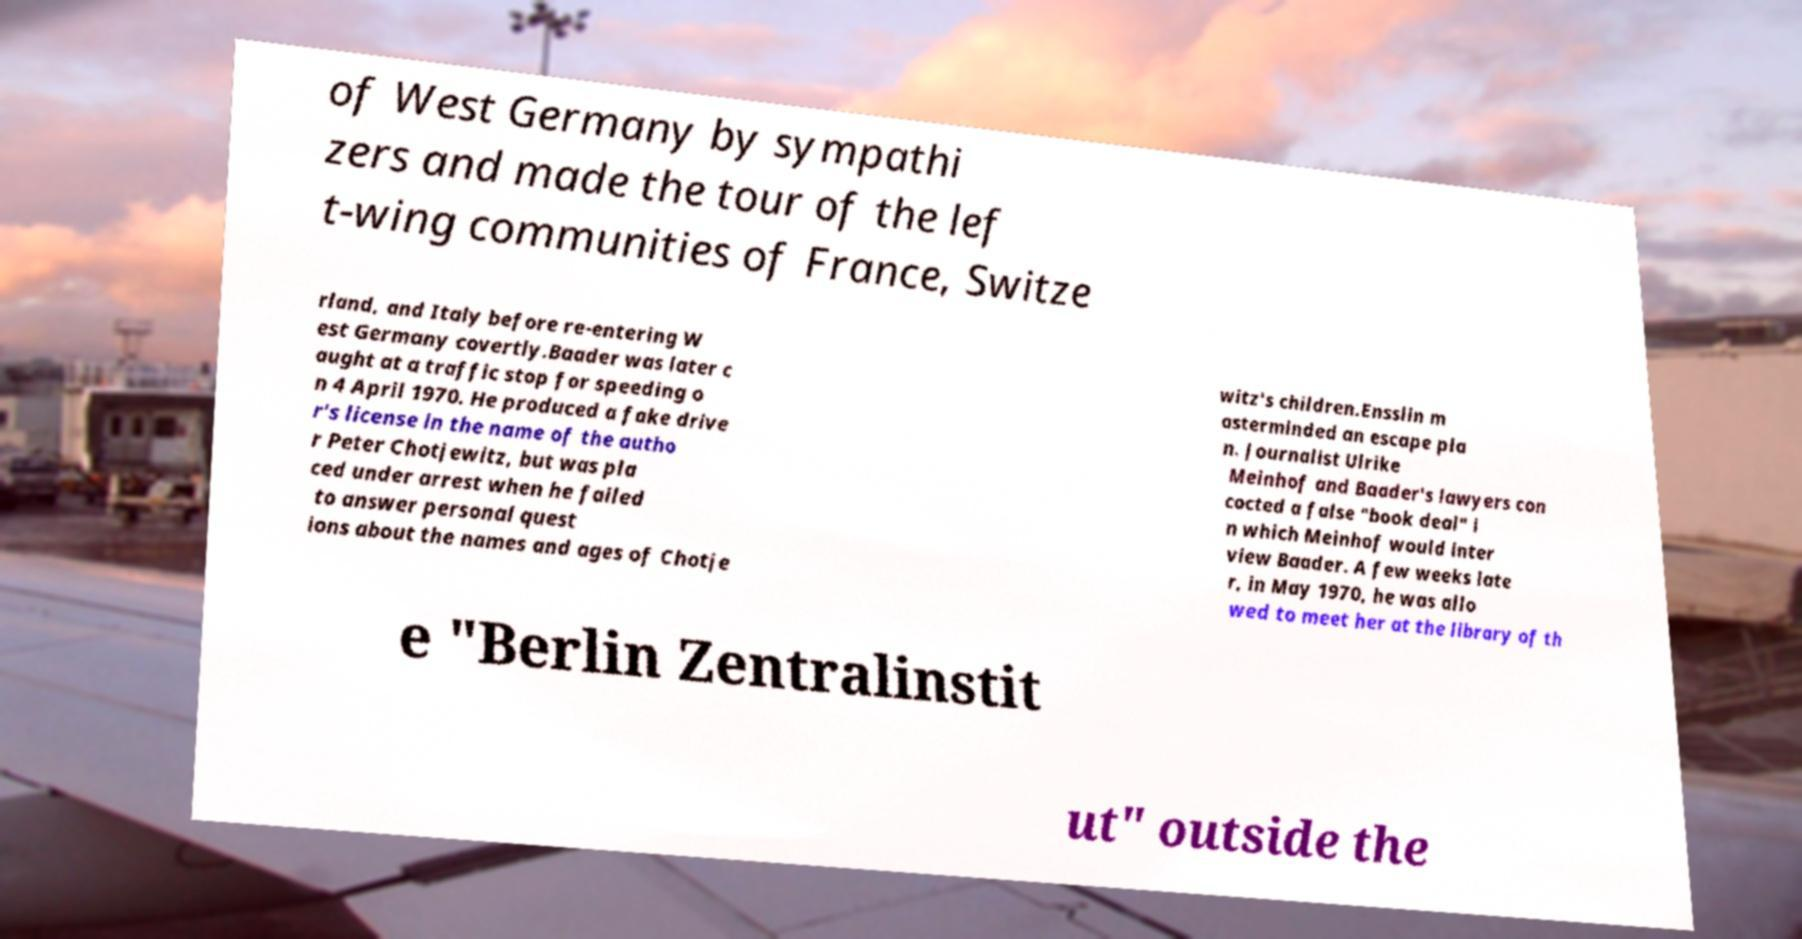Can you read and provide the text displayed in the image?This photo seems to have some interesting text. Can you extract and type it out for me? of West Germany by sympathi zers and made the tour of the lef t-wing communities of France, Switze rland, and Italy before re-entering W est Germany covertly.Baader was later c aught at a traffic stop for speeding o n 4 April 1970. He produced a fake drive r's license in the name of the autho r Peter Chotjewitz, but was pla ced under arrest when he failed to answer personal quest ions about the names and ages of Chotje witz's children.Ensslin m asterminded an escape pla n. Journalist Ulrike Meinhof and Baader's lawyers con cocted a false "book deal" i n which Meinhof would inter view Baader. A few weeks late r, in May 1970, he was allo wed to meet her at the library of th e "Berlin Zentralinstit ut" outside the 